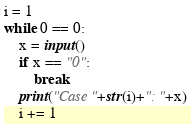Convert code to text. <code><loc_0><loc_0><loc_500><loc_500><_Python_>i = 1
while 0 == 0:
    x = input()
    if x == "0":
        break
    print("Case "+str(i)+": "+x)
    i += 1

</code> 